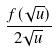<formula> <loc_0><loc_0><loc_500><loc_500>\frac { f ( \sqrt { u } ) } { 2 \sqrt { u } }</formula> 